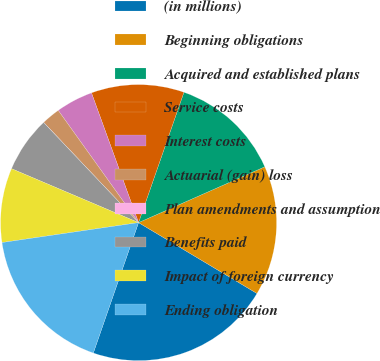Convert chart. <chart><loc_0><loc_0><loc_500><loc_500><pie_chart><fcel>(in millions)<fcel>Beginning obligations<fcel>Acquired and established plans<fcel>Service costs<fcel>Interest costs<fcel>Actuarial (gain) loss<fcel>Plan amendments and assumption<fcel>Benefits paid<fcel>Impact of foreign currency<fcel>Ending obligation<nl><fcel>21.73%<fcel>15.21%<fcel>13.04%<fcel>10.87%<fcel>4.35%<fcel>2.18%<fcel>0.01%<fcel>6.53%<fcel>8.7%<fcel>17.38%<nl></chart> 